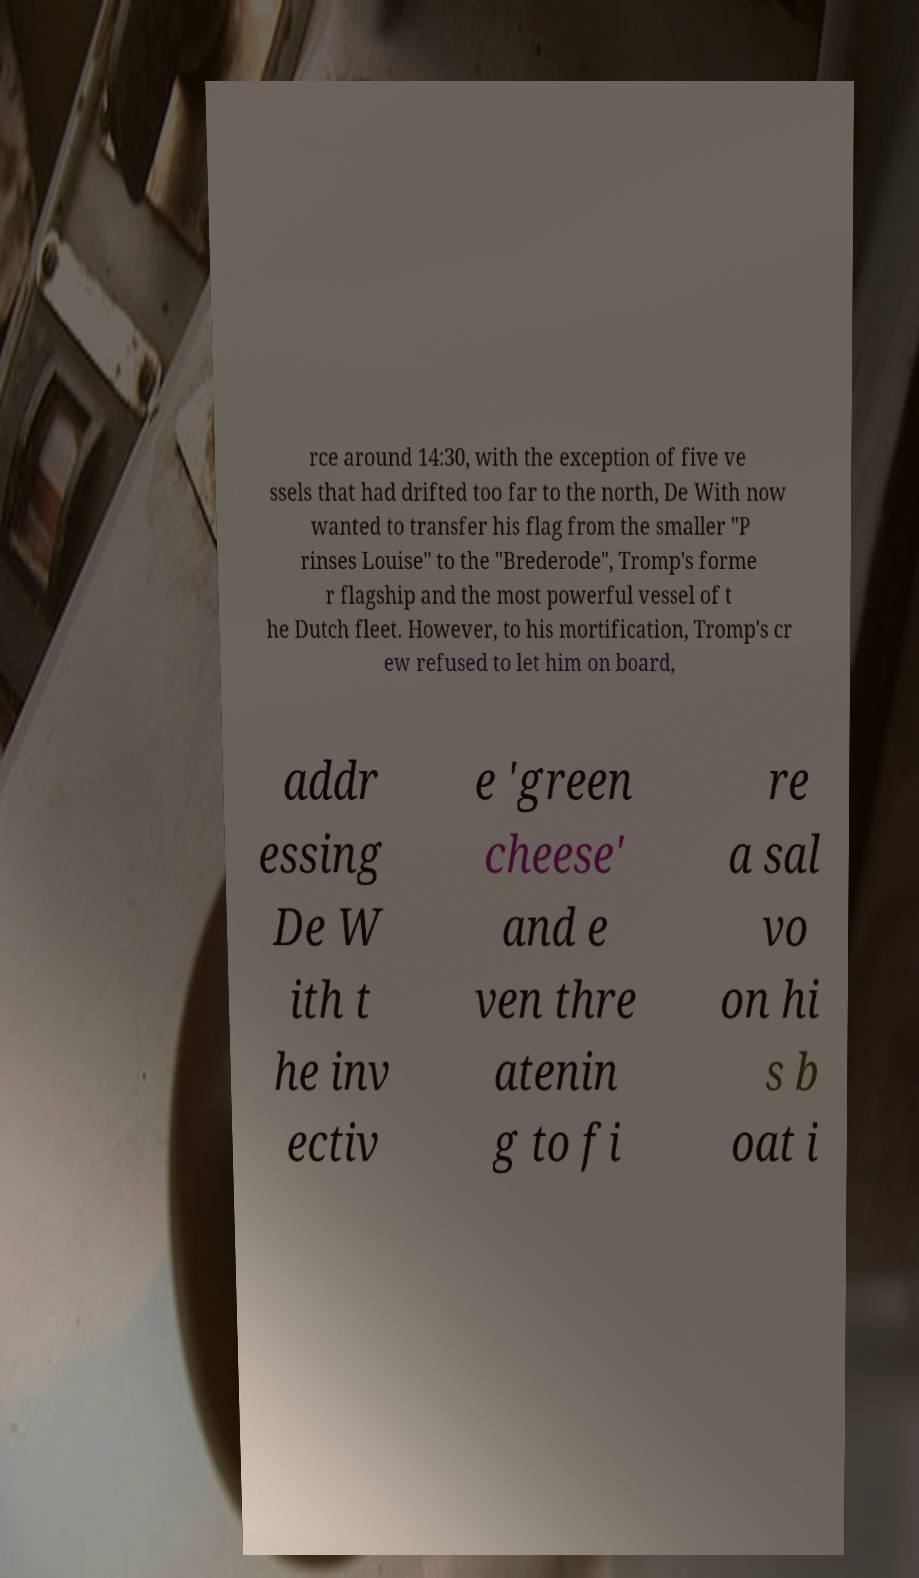Can you accurately transcribe the text from the provided image for me? rce around 14:30, with the exception of five ve ssels that had drifted too far to the north, De With now wanted to transfer his flag from the smaller "P rinses Louise" to the "Brederode", Tromp's forme r flagship and the most powerful vessel of t he Dutch fleet. However, to his mortification, Tromp's cr ew refused to let him on board, addr essing De W ith t he inv ectiv e 'green cheese' and e ven thre atenin g to fi re a sal vo on hi s b oat i 